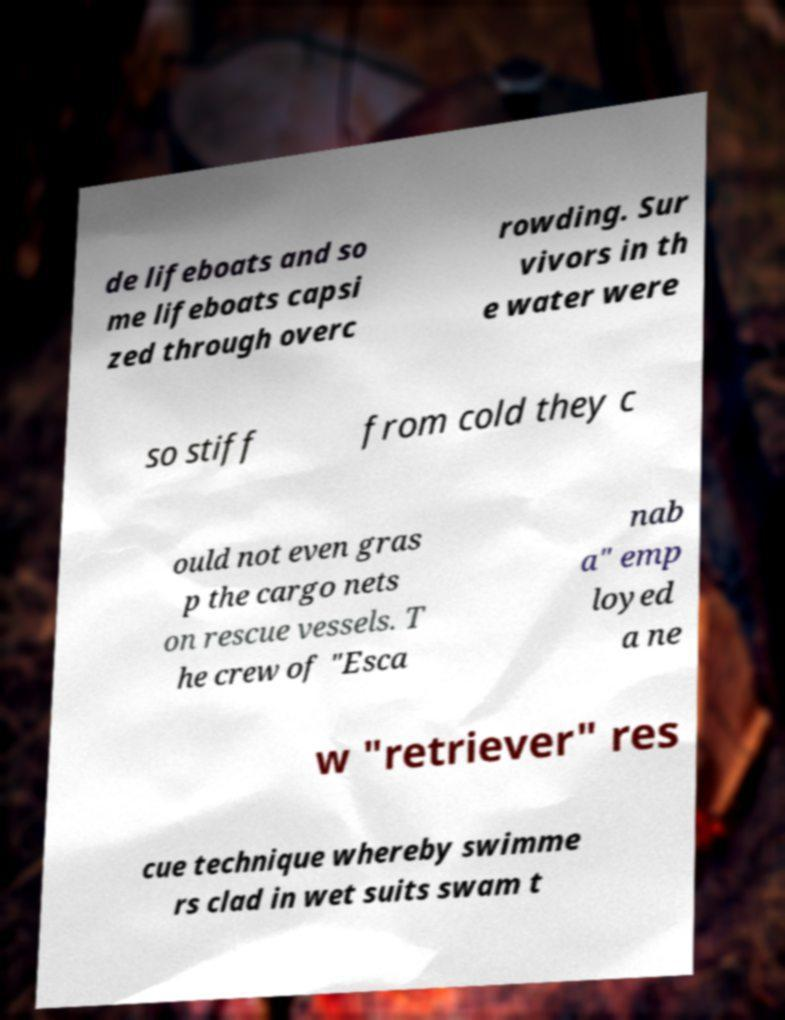For documentation purposes, I need the text within this image transcribed. Could you provide that? de lifeboats and so me lifeboats capsi zed through overc rowding. Sur vivors in th e water were so stiff from cold they c ould not even gras p the cargo nets on rescue vessels. T he crew of "Esca nab a" emp loyed a ne w "retriever" res cue technique whereby swimme rs clad in wet suits swam t 